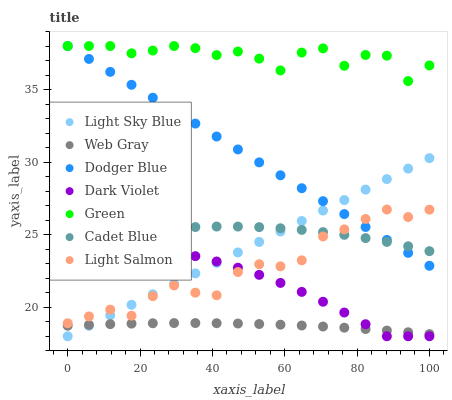Does Web Gray have the minimum area under the curve?
Answer yes or no. Yes. Does Green have the maximum area under the curve?
Answer yes or no. Yes. Does Cadet Blue have the minimum area under the curve?
Answer yes or no. No. Does Cadet Blue have the maximum area under the curve?
Answer yes or no. No. Is Dodger Blue the smoothest?
Answer yes or no. Yes. Is Green the roughest?
Answer yes or no. Yes. Is Cadet Blue the smoothest?
Answer yes or no. No. Is Cadet Blue the roughest?
Answer yes or no. No. Does Dark Violet have the lowest value?
Answer yes or no. Yes. Does Cadet Blue have the lowest value?
Answer yes or no. No. Does Green have the highest value?
Answer yes or no. Yes. Does Cadet Blue have the highest value?
Answer yes or no. No. Is Dark Violet less than Dodger Blue?
Answer yes or no. Yes. Is Dodger Blue greater than Web Gray?
Answer yes or no. Yes. Does Dark Violet intersect Light Salmon?
Answer yes or no. Yes. Is Dark Violet less than Light Salmon?
Answer yes or no. No. Is Dark Violet greater than Light Salmon?
Answer yes or no. No. Does Dark Violet intersect Dodger Blue?
Answer yes or no. No. 